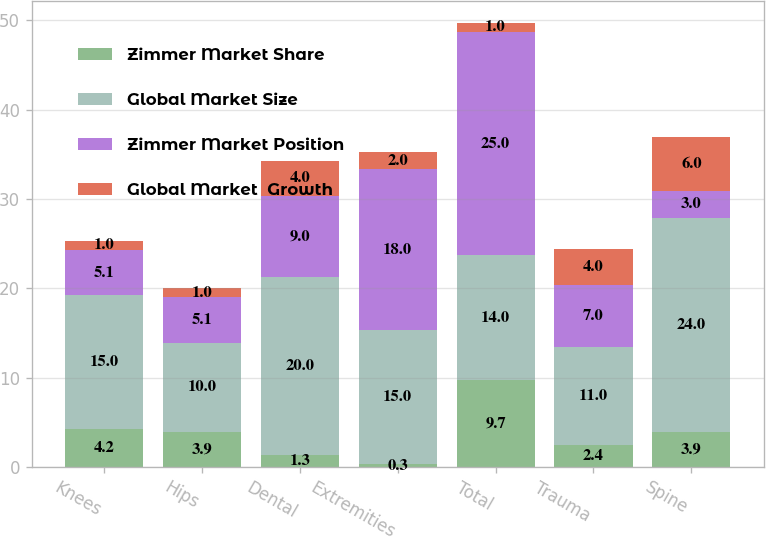<chart> <loc_0><loc_0><loc_500><loc_500><stacked_bar_chart><ecel><fcel>Knees<fcel>Hips<fcel>Dental<fcel>Extremities<fcel>Total<fcel>Trauma<fcel>Spine<nl><fcel>Zimmer Market Share<fcel>4.2<fcel>3.9<fcel>1.3<fcel>0.3<fcel>9.7<fcel>2.4<fcel>3.9<nl><fcel>Global Market Size<fcel>15<fcel>10<fcel>20<fcel>15<fcel>14<fcel>11<fcel>24<nl><fcel>Zimmer Market Position<fcel>5.1<fcel>5.1<fcel>9<fcel>18<fcel>25<fcel>7<fcel>3<nl><fcel>Global Market  Growth<fcel>1<fcel>1<fcel>4<fcel>2<fcel>1<fcel>4<fcel>6<nl></chart> 